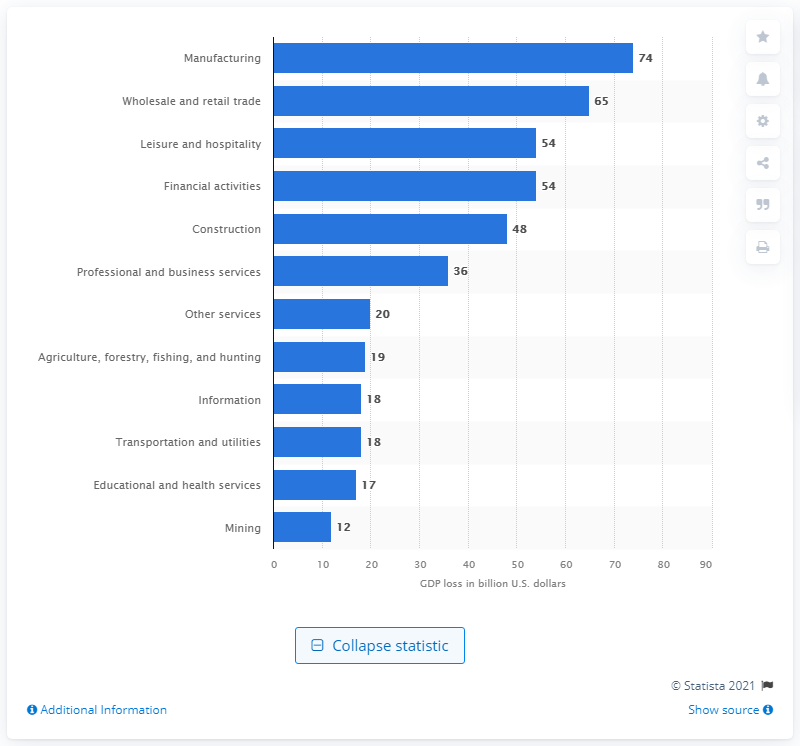Point out several critical features in this image. In September 2016, if all illegal immigrant workers were removed from the United States, the manufacturing industry would likely suffer a significant loss. 